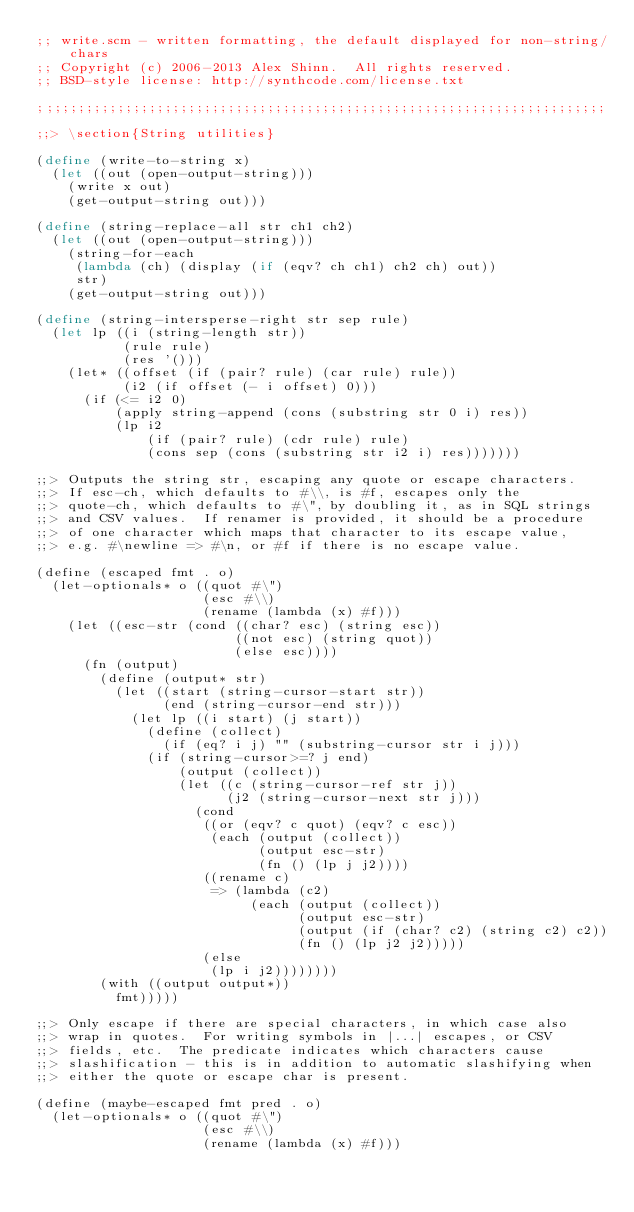<code> <loc_0><loc_0><loc_500><loc_500><_Scheme_>;; write.scm - written formatting, the default displayed for non-string/chars
;; Copyright (c) 2006-2013 Alex Shinn.  All rights reserved.
;; BSD-style license: http://synthcode.com/license.txt

;;;;;;;;;;;;;;;;;;;;;;;;;;;;;;;;;;;;;;;;;;;;;;;;;;;;;;;;;;;;;;;;;;;;;;;;

;;> \section{String utilities}

(define (write-to-string x)
  (let ((out (open-output-string)))
    (write x out)
    (get-output-string out)))

(define (string-replace-all str ch1 ch2)
  (let ((out (open-output-string)))
    (string-for-each
     (lambda (ch) (display (if (eqv? ch ch1) ch2 ch) out))
     str)
    (get-output-string out)))

(define (string-intersperse-right str sep rule)
  (let lp ((i (string-length str))
           (rule rule)
           (res '()))
    (let* ((offset (if (pair? rule) (car rule) rule))
           (i2 (if offset (- i offset) 0)))
      (if (<= i2 0)
          (apply string-append (cons (substring str 0 i) res))
          (lp i2
              (if (pair? rule) (cdr rule) rule)
              (cons sep (cons (substring str i2 i) res)))))))

;;> Outputs the string str, escaping any quote or escape characters.
;;> If esc-ch, which defaults to #\\, is #f, escapes only the
;;> quote-ch, which defaults to #\", by doubling it, as in SQL strings
;;> and CSV values.  If renamer is provided, it should be a procedure
;;> of one character which maps that character to its escape value,
;;> e.g. #\newline => #\n, or #f if there is no escape value.

(define (escaped fmt . o)
  (let-optionals* o ((quot #\")
                     (esc #\\)
                     (rename (lambda (x) #f)))
    (let ((esc-str (cond ((char? esc) (string esc))
                         ((not esc) (string quot))
                         (else esc))))
      (fn (output)
        (define (output* str)
          (let ((start (string-cursor-start str))
                (end (string-cursor-end str)))
            (let lp ((i start) (j start))
              (define (collect)
                (if (eq? i j) "" (substring-cursor str i j)))
              (if (string-cursor>=? j end)
                  (output (collect))
                  (let ((c (string-cursor-ref str j))
                        (j2 (string-cursor-next str j)))
                    (cond
                     ((or (eqv? c quot) (eqv? c esc))
                      (each (output (collect))
                            (output esc-str)
                            (fn () (lp j j2))))
                     ((rename c)
                      => (lambda (c2)
                           (each (output (collect))
                                 (output esc-str)
                                 (output (if (char? c2) (string c2) c2))
                                 (fn () (lp j2 j2)))))
                     (else
                      (lp i j2))))))))
        (with ((output output*))
          fmt)))))

;;> Only escape if there are special characters, in which case also
;;> wrap in quotes.  For writing symbols in |...| escapes, or CSV
;;> fields, etc.  The predicate indicates which characters cause
;;> slashification - this is in addition to automatic slashifying when
;;> either the quote or escape char is present.

(define (maybe-escaped fmt pred . o)
  (let-optionals* o ((quot #\")
                     (esc #\\)
                     (rename (lambda (x) #f)))</code> 